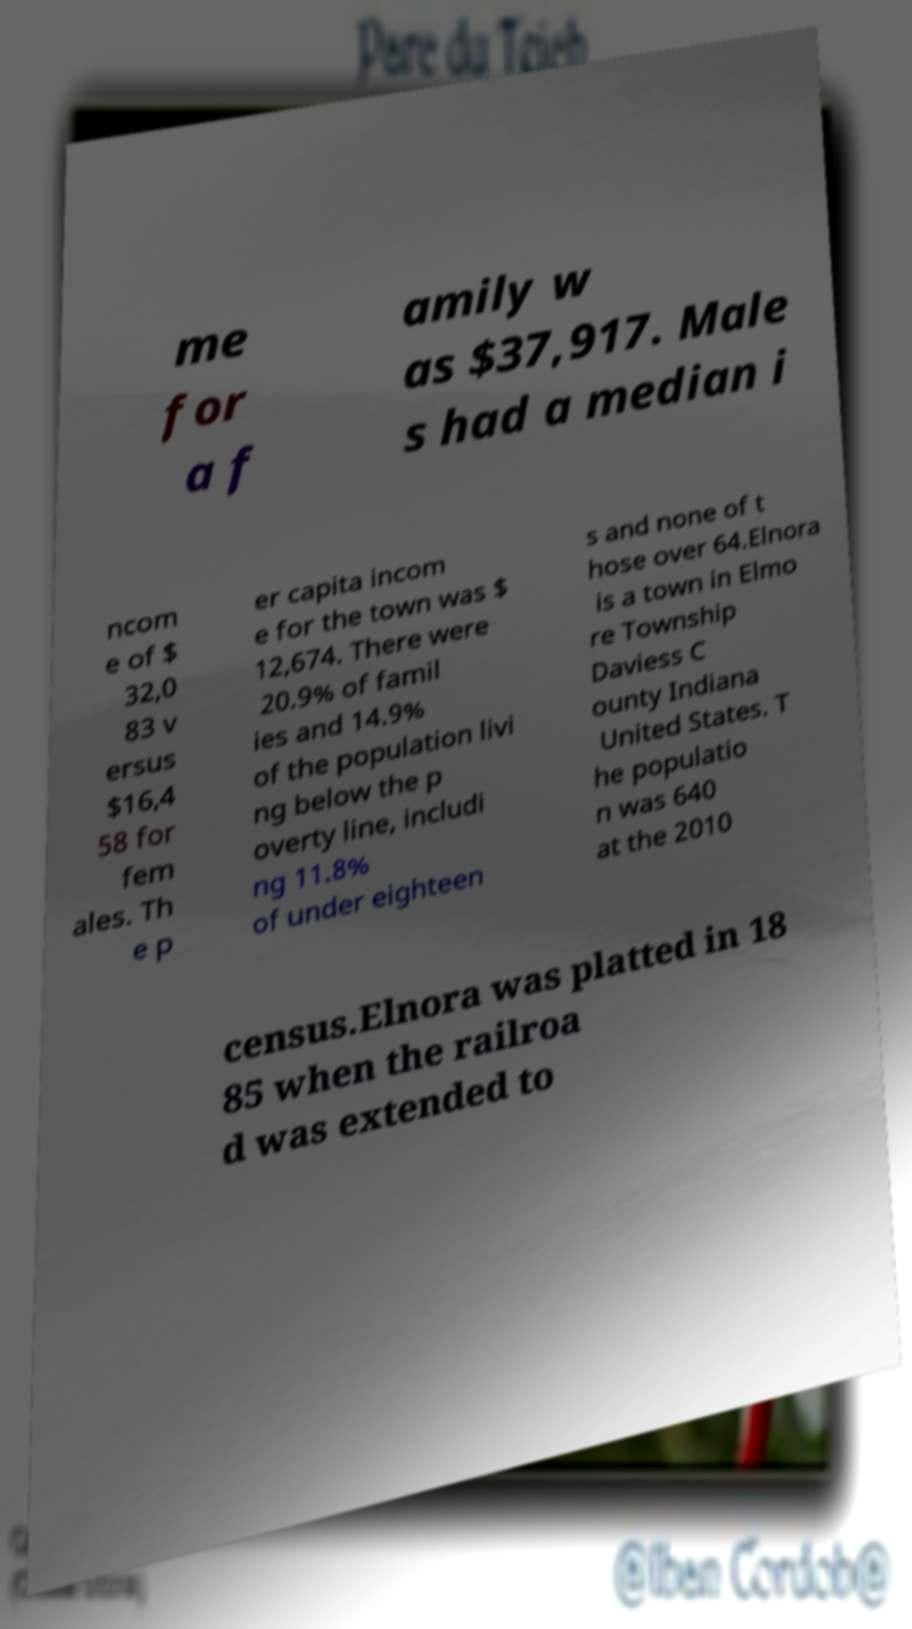Could you assist in decoding the text presented in this image and type it out clearly? me for a f amily w as $37,917. Male s had a median i ncom e of $ 32,0 83 v ersus $16,4 58 for fem ales. Th e p er capita incom e for the town was $ 12,674. There were 20.9% of famil ies and 14.9% of the population livi ng below the p overty line, includi ng 11.8% of under eighteen s and none of t hose over 64.Elnora is a town in Elmo re Township Daviess C ounty Indiana United States. T he populatio n was 640 at the 2010 census.Elnora was platted in 18 85 when the railroa d was extended to 